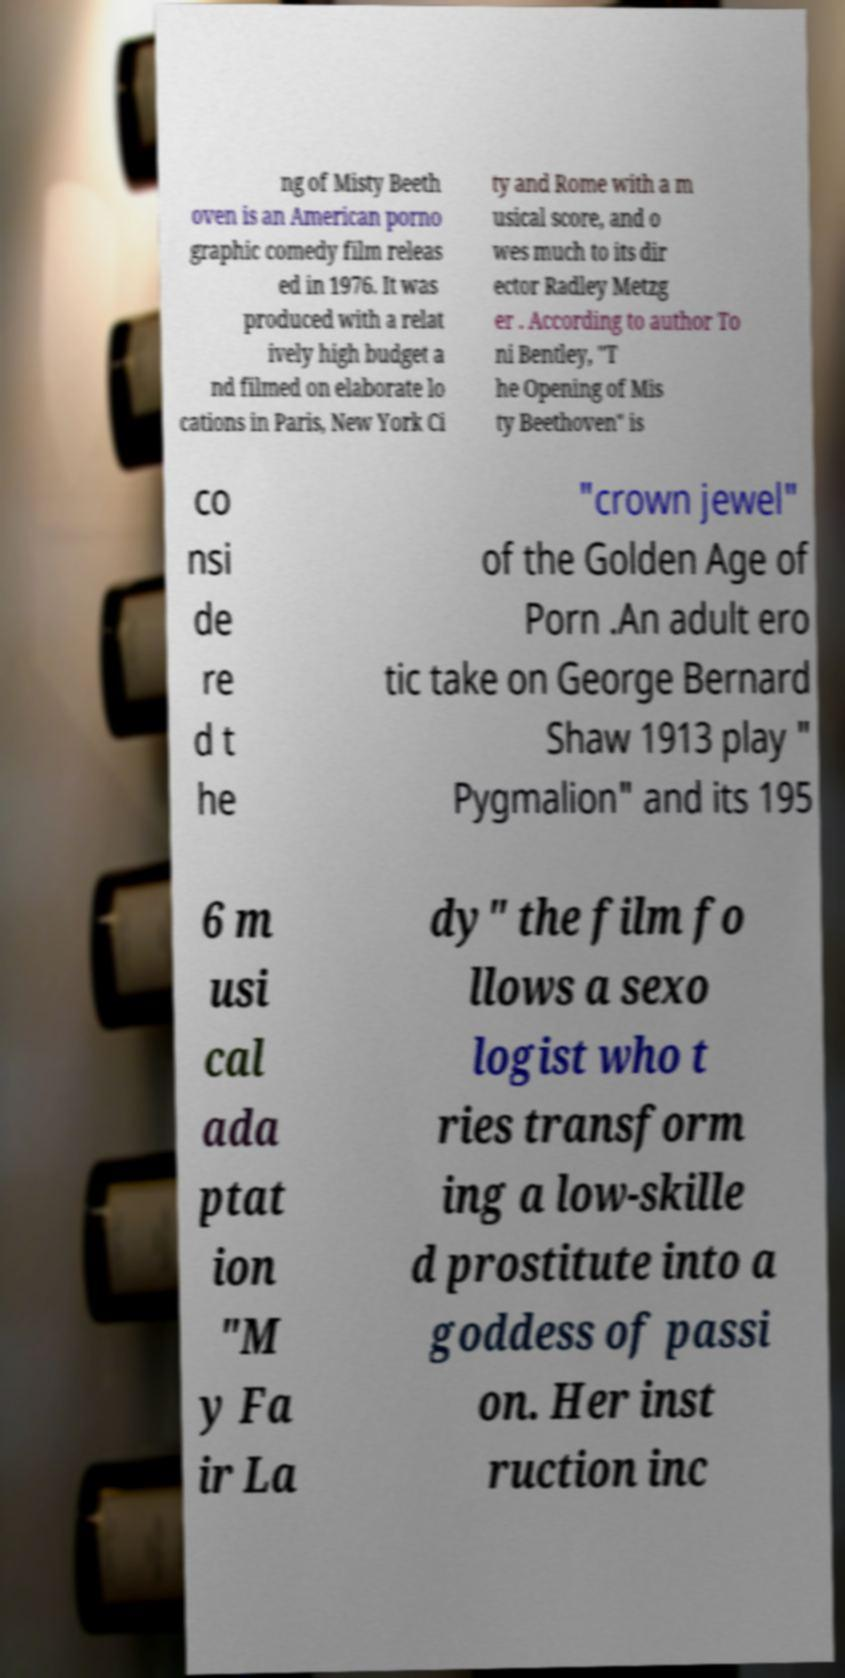Please read and relay the text visible in this image. What does it say? ng of Misty Beeth oven is an American porno graphic comedy film releas ed in 1976. It was produced with a relat ively high budget a nd filmed on elaborate lo cations in Paris, New York Ci ty and Rome with a m usical score, and o wes much to its dir ector Radley Metzg er . According to author To ni Bentley, "T he Opening of Mis ty Beethoven" is co nsi de re d t he "crown jewel" of the Golden Age of Porn .An adult ero tic take on George Bernard Shaw 1913 play " Pygmalion" and its 195 6 m usi cal ada ptat ion "M y Fa ir La dy" the film fo llows a sexo logist who t ries transform ing a low-skille d prostitute into a goddess of passi on. Her inst ruction inc 